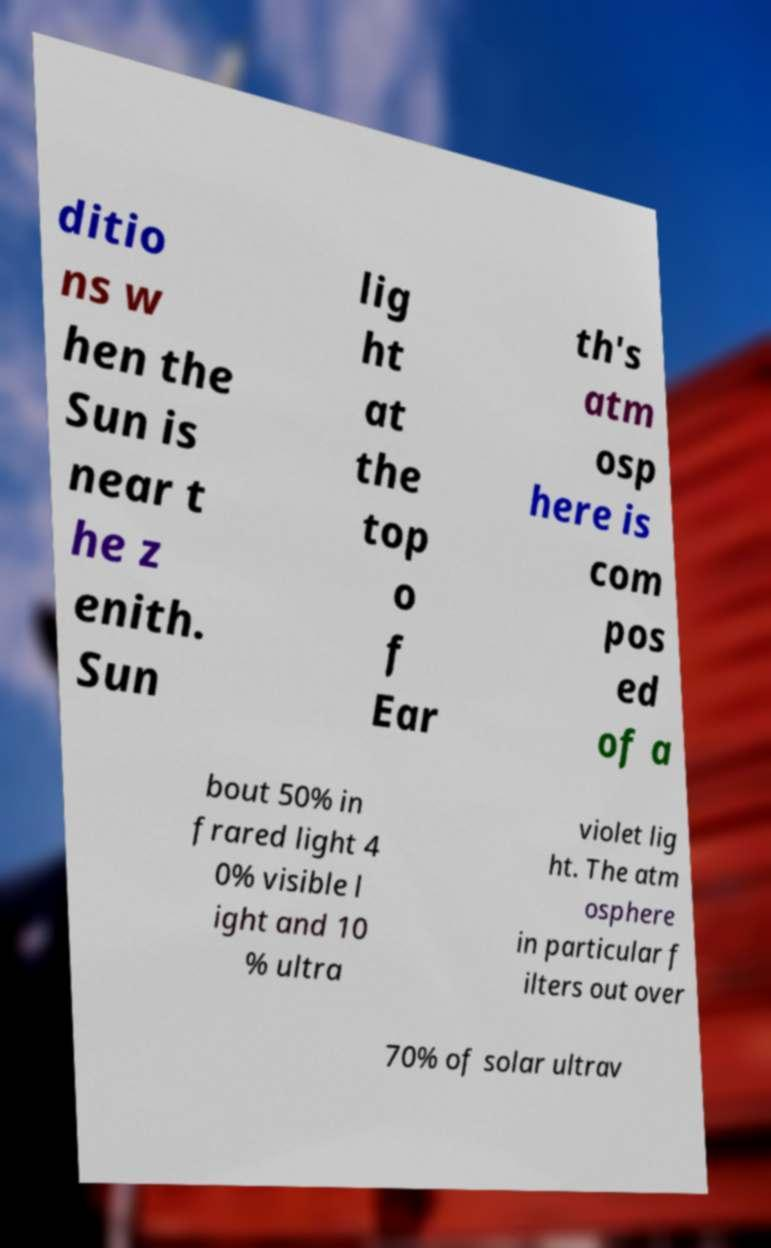Please read and relay the text visible in this image. What does it say? ditio ns w hen the Sun is near t he z enith. Sun lig ht at the top o f Ear th's atm osp here is com pos ed of a bout 50% in frared light 4 0% visible l ight and 10 % ultra violet lig ht. The atm osphere in particular f ilters out over 70% of solar ultrav 